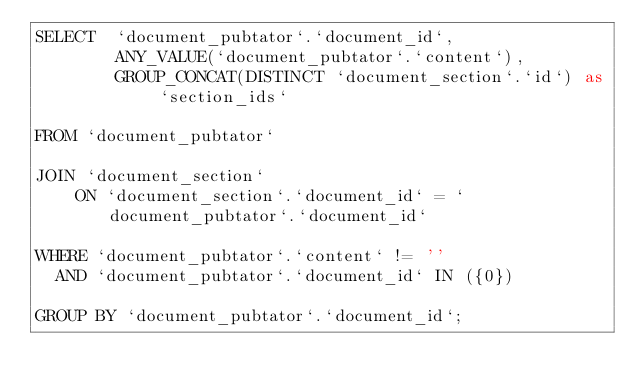<code> <loc_0><loc_0><loc_500><loc_500><_SQL_>SELECT  `document_pubtator`.`document_id`,
        ANY_VALUE(`document_pubtator`.`content`),
        GROUP_CONCAT(DISTINCT `document_section`.`id`) as `section_ids`

FROM `document_pubtator`

JOIN `document_section`
    ON `document_section`.`document_id` = `document_pubtator`.`document_id`

WHERE `document_pubtator`.`content` != ''
  AND `document_pubtator`.`document_id` IN ({0})

GROUP BY `document_pubtator`.`document_id`;
</code> 